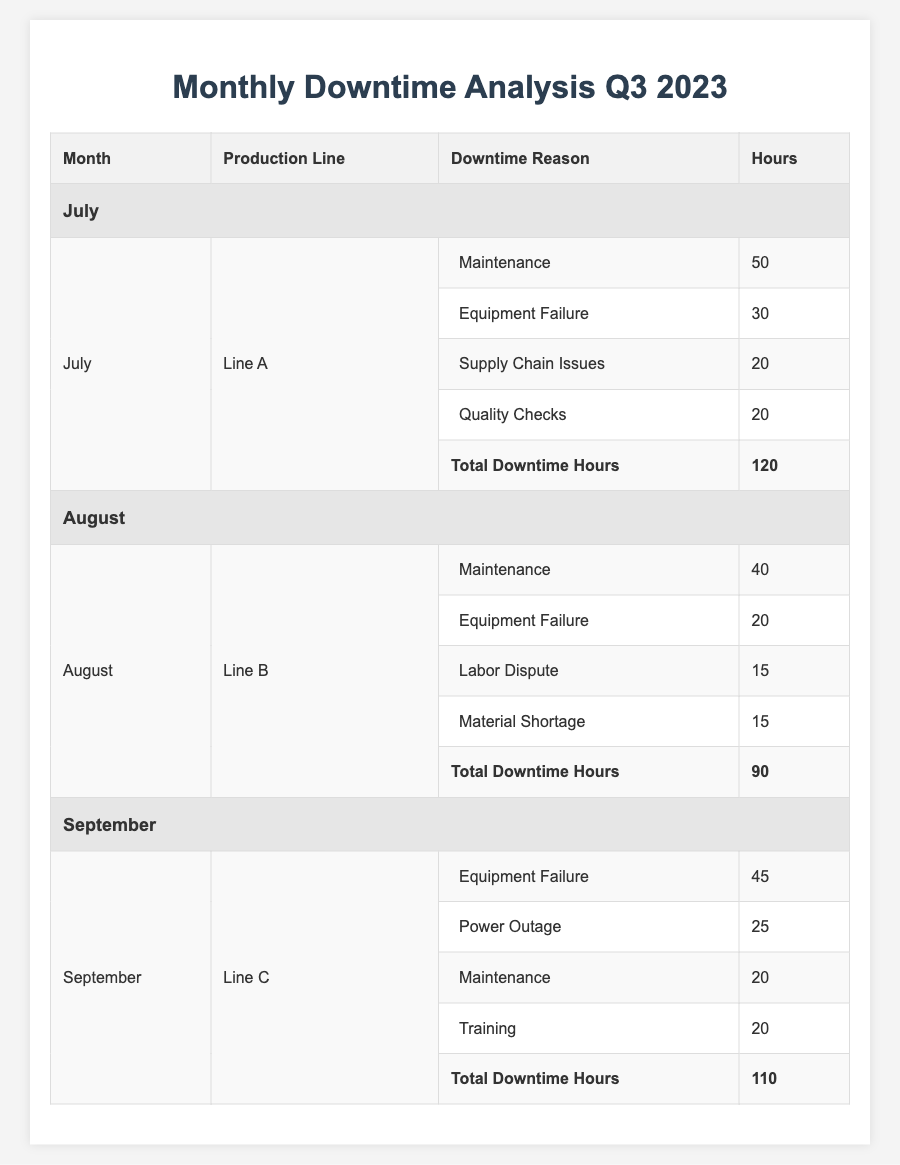What is the total downtime for Line A in July? The total downtime hours for Line A in July can be directly retrieved from the table, which shows a total of 120 hours.
Answer: 120 Which production line had the least total downtime in Q3 2023? By comparing the total downtime hours for July (120), August (90), and September (110), August shows the least downtime with 90 hours for Line B.
Answer: Line B How many hours of downtime in September were caused by equipment failure? The table lists equipment failure as a reason for downtime in September with 45 hours.
Answer: 45 What were the total downtime hours for Line B in August? The table indicates that Line B had a total of 90 hours of downtime in August.
Answer: 90 Was maintenance a reason for downtime in all three months? Maintenance was recorded as a reason for downtime in July (50 hours), August (40 hours), and September (20 hours), confirming it was present in all three months.
Answer: Yes What is the average downtime for Line C across its listed reasons in September? Adding the hours for Line C's reasons: 45 + 25 + 20 + 20 = 110 hours; dividing the total by 4 reasons gives an average of 110/4 = 27.5 hours.
Answer: 27.5 In which month did supply chain issues contribute to downtime, and how many hours? The table indicates that supply chain issues contributed 20 hours of downtime in July for Line A only.
Answer: July, 20 hours If we compare the total downtime of July and September, which month had more downtime? July had 120 hours and September had 110 hours; since 120 > 110, July had more downtime.
Answer: July What is the total downtime caused by equipment failure across all months? Equipment failure hours are 30 (July) + 20 (August) + 45 (September) = 95 hours.
Answer: 95 Which reason accounted for the most downtime in August? In August, maintenance accounted for the most downtime at 40 hours, more than any other listed reason.
Answer: Maintenance at 40 hours 